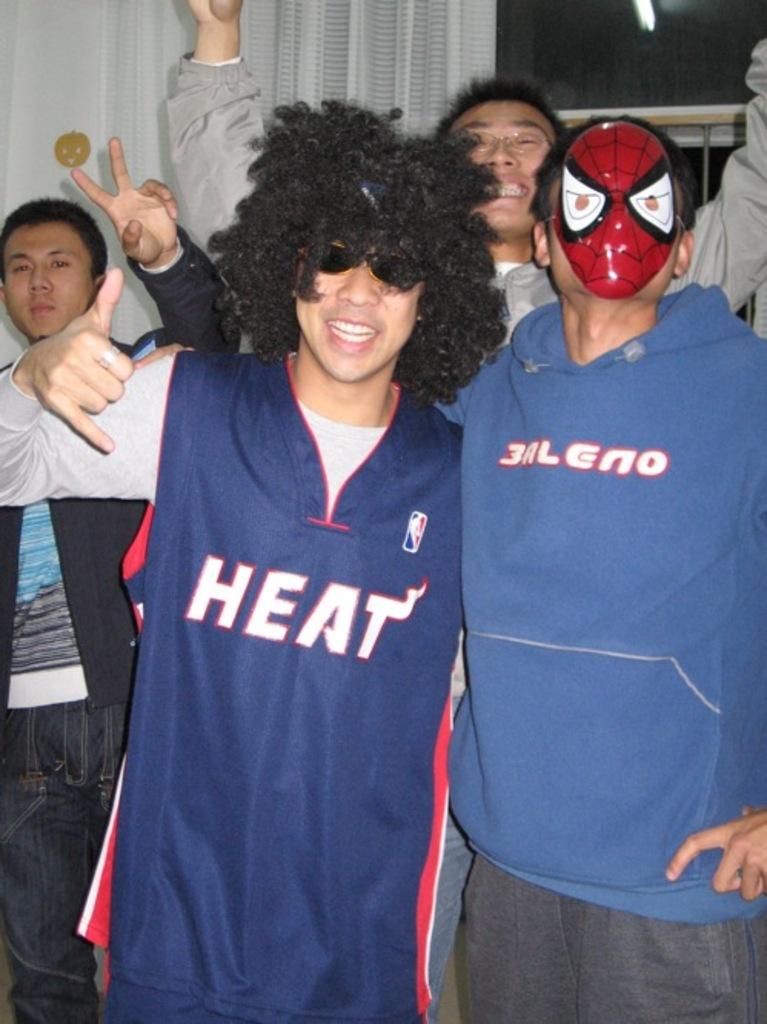What team is on his shirt?
Your response must be concise. Heat. What does the sweatshirt on the right say?
Give a very brief answer. 3aleno. 